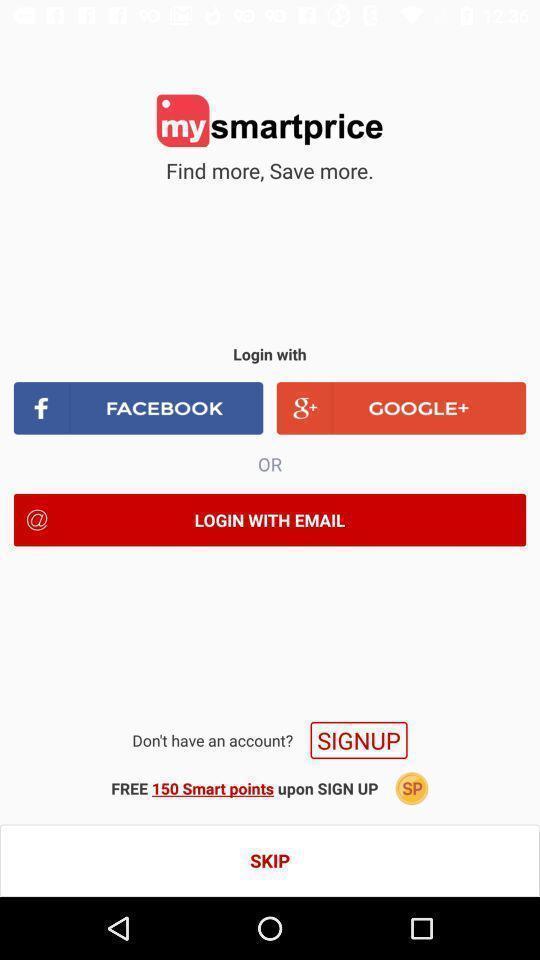Summarize the main components in this picture. Sign up page for a shopping application. 